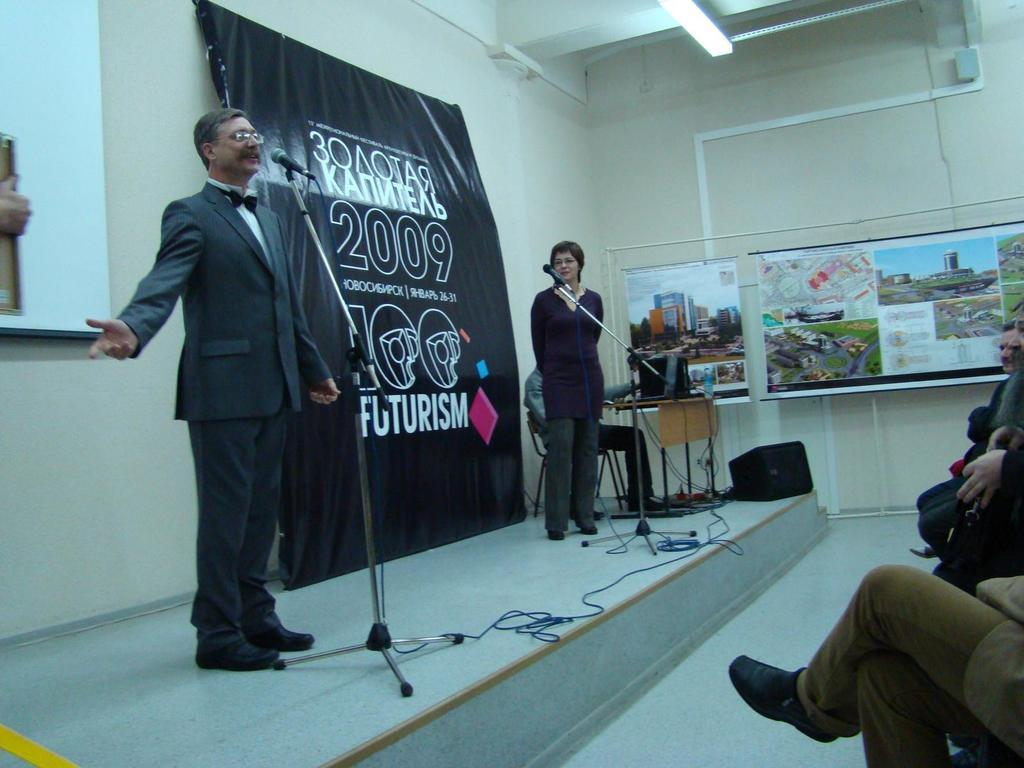<image>
Relay a brief, clear account of the picture shown. A man and woman are speaking into microphones on a stage and the sign behind them says 2009 Futurism. 